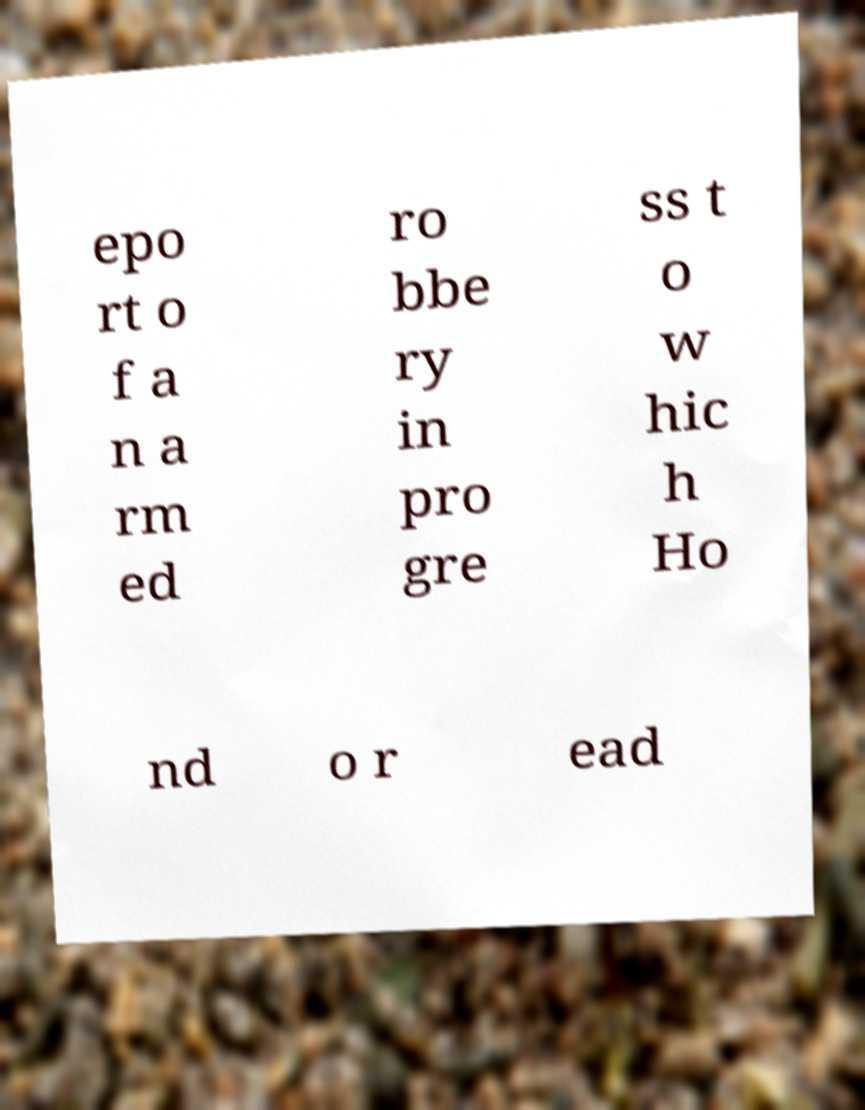There's text embedded in this image that I need extracted. Can you transcribe it verbatim? epo rt o f a n a rm ed ro bbe ry in pro gre ss t o w hic h Ho nd o r ead 